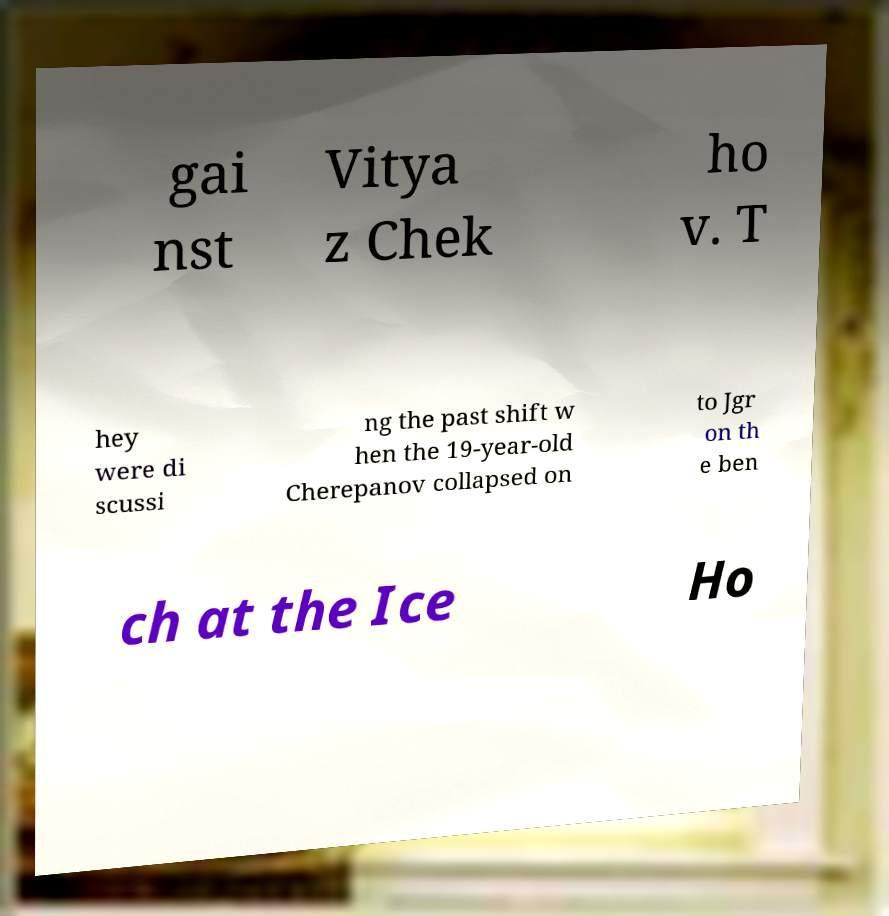For documentation purposes, I need the text within this image transcribed. Could you provide that? gai nst Vitya z Chek ho v. T hey were di scussi ng the past shift w hen the 19-year-old Cherepanov collapsed on to Jgr on th e ben ch at the Ice Ho 